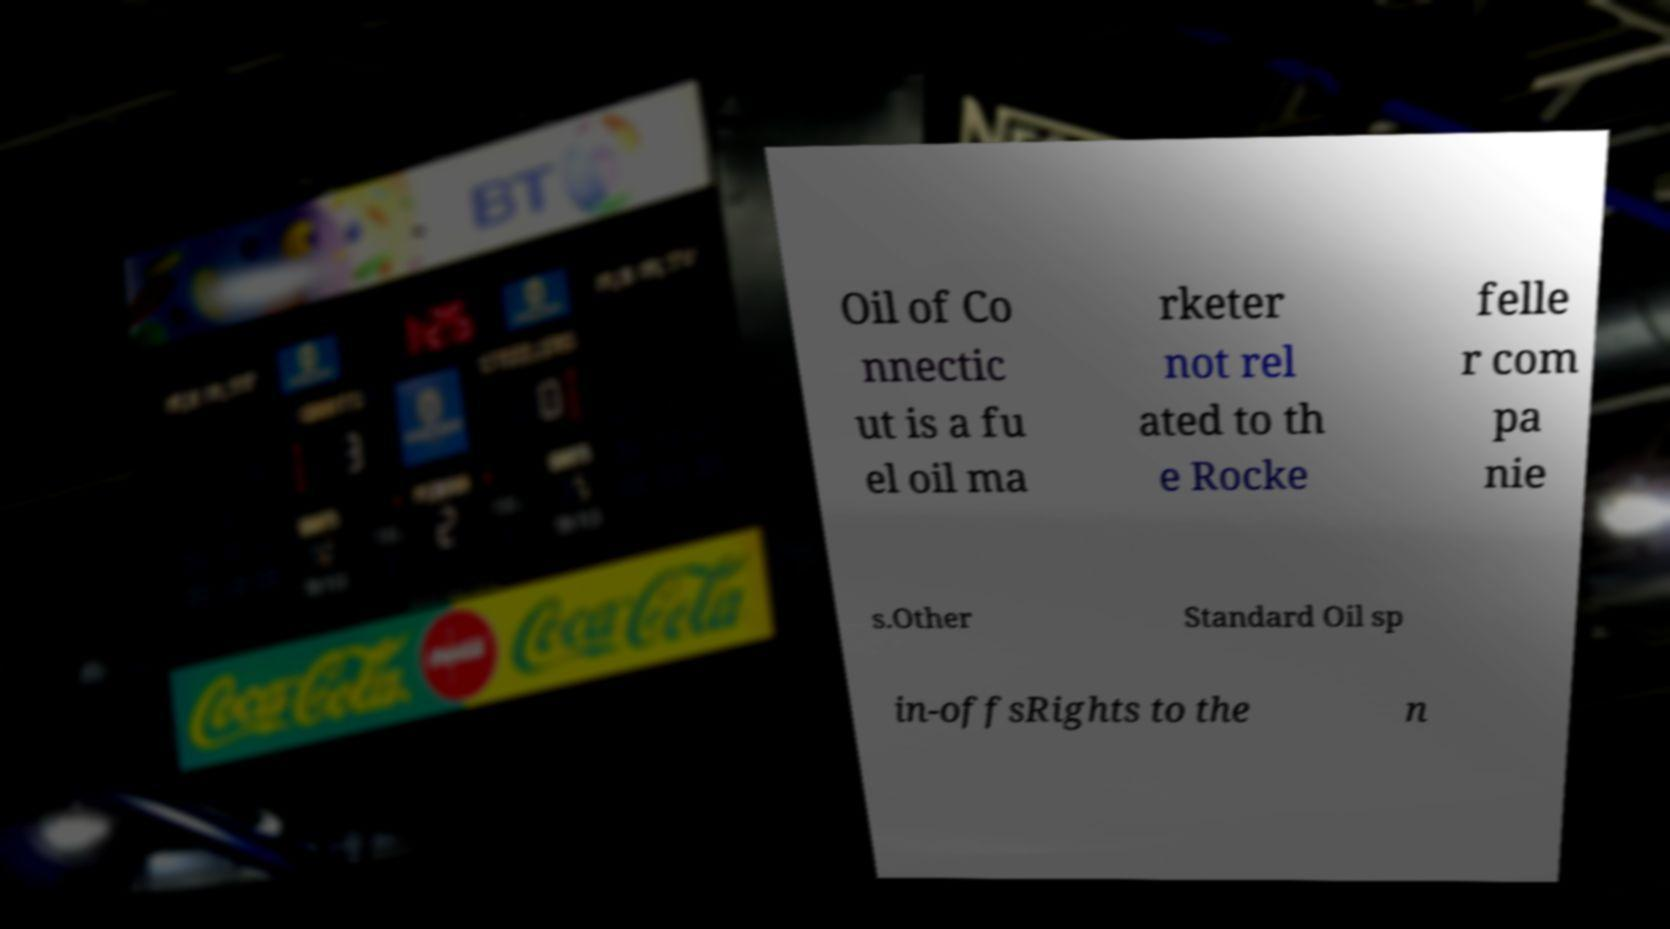What messages or text are displayed in this image? I need them in a readable, typed format. Oil of Co nnectic ut is a fu el oil ma rketer not rel ated to th e Rocke felle r com pa nie s.Other Standard Oil sp in-offsRights to the n 